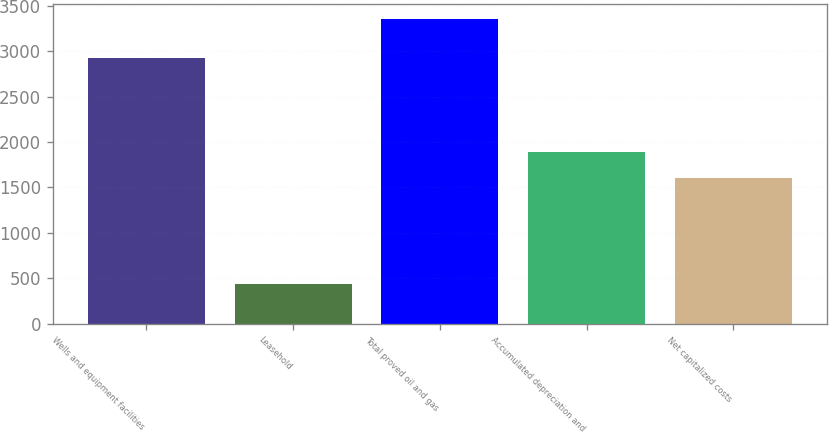Convert chart to OTSL. <chart><loc_0><loc_0><loc_500><loc_500><bar_chart><fcel>Wells and equipment facilities<fcel>Leasehold<fcel>Total proved oil and gas<fcel>Accumulated depreciation and<fcel>Net capitalized costs<nl><fcel>2920.7<fcel>433.5<fcel>3354.2<fcel>1892.47<fcel>1600.4<nl></chart> 